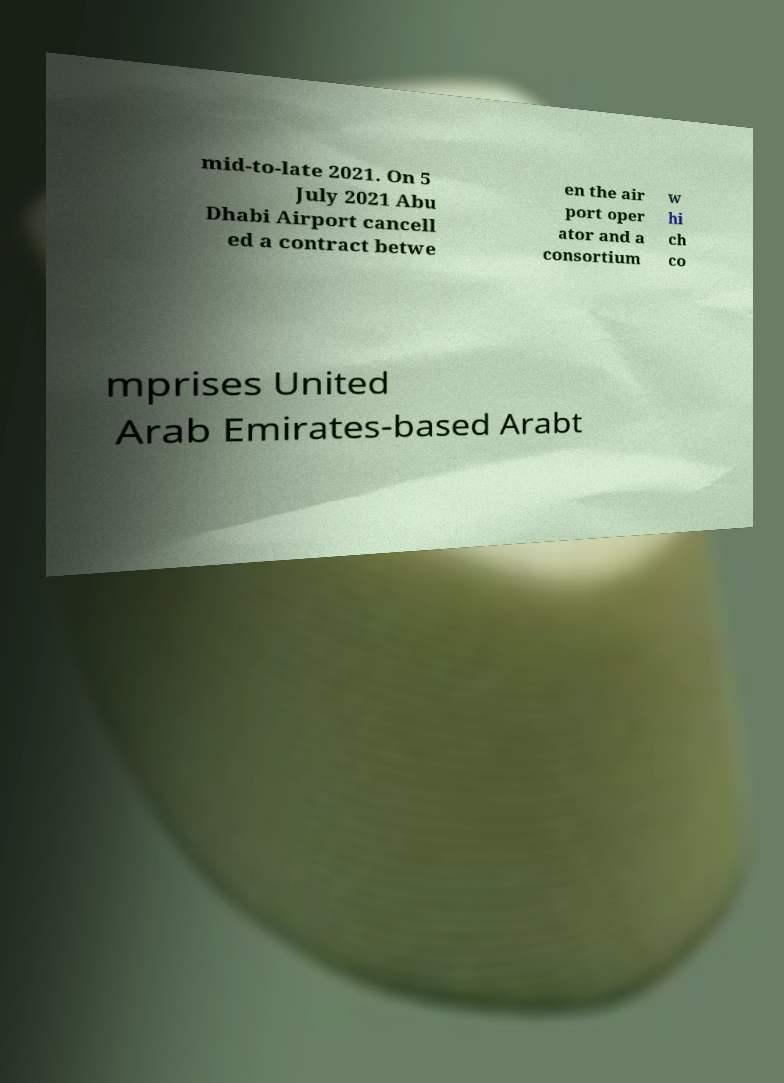There's text embedded in this image that I need extracted. Can you transcribe it verbatim? mid-to-late 2021. On 5 July 2021 Abu Dhabi Airport cancell ed a contract betwe en the air port oper ator and a consortium w hi ch co mprises United Arab Emirates-based Arabt 